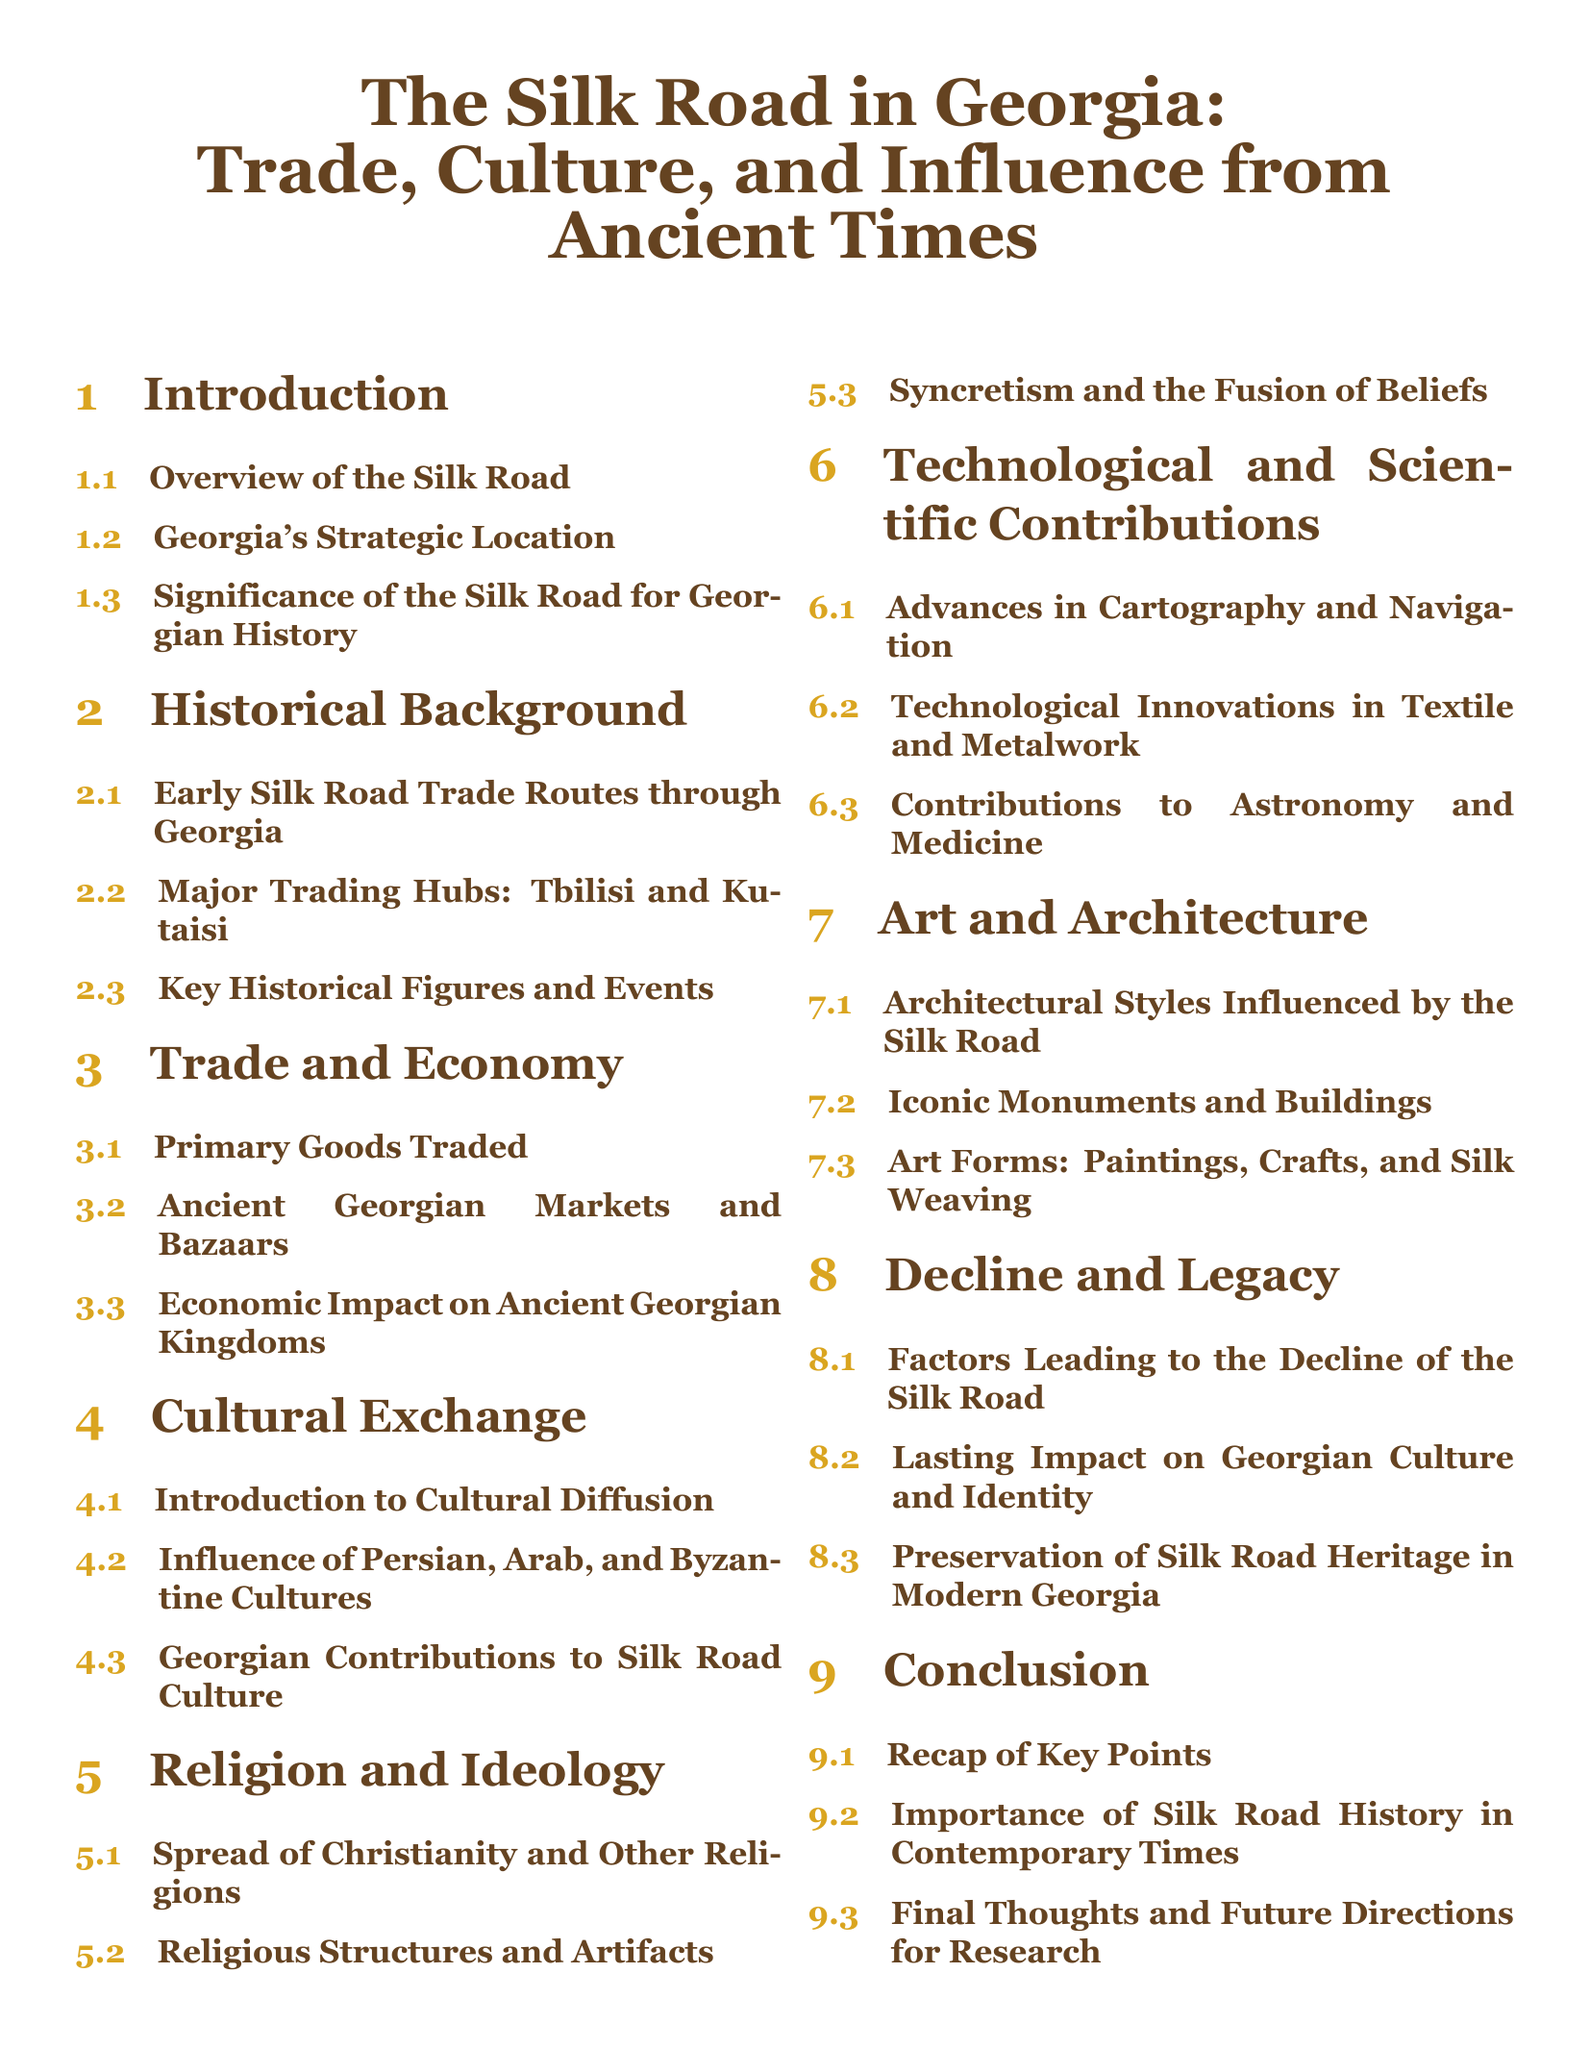What is the focus of the document? The title indicates that the document focuses on the Silk Road in Georgia, covering trade, culture, and influence from ancient times.
Answer: The Silk Road in Georgia: Trade, Culture, and Influence from Ancient Times Which section discusses Georgia's strategic location? The section titled "Georgia's Strategic Location" specifically addresses the importance of Georgia's geographical position along the Silk Road.
Answer: Georgia's Strategic Location What are the two major trading hubs mentioned? The document lists Tbilisi and Kutaisi as significant trading hubs in the context of Silk Road trade.
Answer: Tbilisi and Kutaisi Which cultures influenced Georgia according to the document? The influence of Persian, Arab, and Byzantine cultures is highlighted under cultural exchange.
Answer: Persian, Arab, and Byzantine Cultures What technological advancement related to navigation is covered? The document mentions advances in cartography and navigation under technological and scientific contributions.
Answer: Cartography and Navigation What factors contributed to the decline of the Silk Road? The section titled "Factors Leading to the Decline of the Silk Road" would address the reasons for the decline.
Answer: Factors Leading to the Decline of the Silk Road What is one major contribution of Georgia to Silk Road culture? The subsection on Georgian contributions to Silk Road culture discusses this aspect in detail.
Answer: Georgian Contributions to Silk Road Culture How are architectural styles described in the document? The section covers "Architectural Styles Influenced by the Silk Road," which discusses how the Silk Road impacted Georgian architecture.
Answer: Architectural Styles Influenced by the Silk Road What is discussed under the conclusion? The conclusion section includes a recap of key points related to the Silk Road's significance in contemporary times.
Answer: Recap of Key Points 